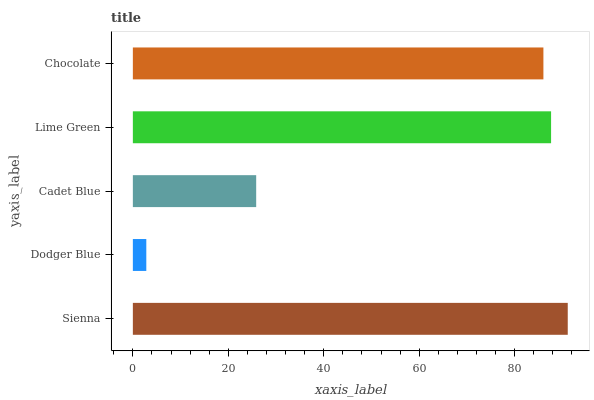Is Dodger Blue the minimum?
Answer yes or no. Yes. Is Sienna the maximum?
Answer yes or no. Yes. Is Cadet Blue the minimum?
Answer yes or no. No. Is Cadet Blue the maximum?
Answer yes or no. No. Is Cadet Blue greater than Dodger Blue?
Answer yes or no. Yes. Is Dodger Blue less than Cadet Blue?
Answer yes or no. Yes. Is Dodger Blue greater than Cadet Blue?
Answer yes or no. No. Is Cadet Blue less than Dodger Blue?
Answer yes or no. No. Is Chocolate the high median?
Answer yes or no. Yes. Is Chocolate the low median?
Answer yes or no. Yes. Is Lime Green the high median?
Answer yes or no. No. Is Lime Green the low median?
Answer yes or no. No. 